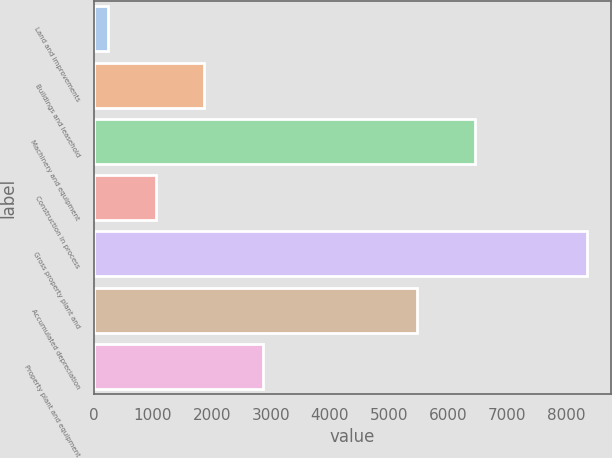Convert chart to OTSL. <chart><loc_0><loc_0><loc_500><loc_500><bar_chart><fcel>Land and improvements<fcel>Buildings and leasehold<fcel>Machinery and equipment<fcel>Construction in process<fcel>Gross property plant and<fcel>Accumulated depreciation<fcel>Property plant and equipment<nl><fcel>243<fcel>1863.2<fcel>6448<fcel>1053.1<fcel>8344<fcel>5477<fcel>2867<nl></chart> 